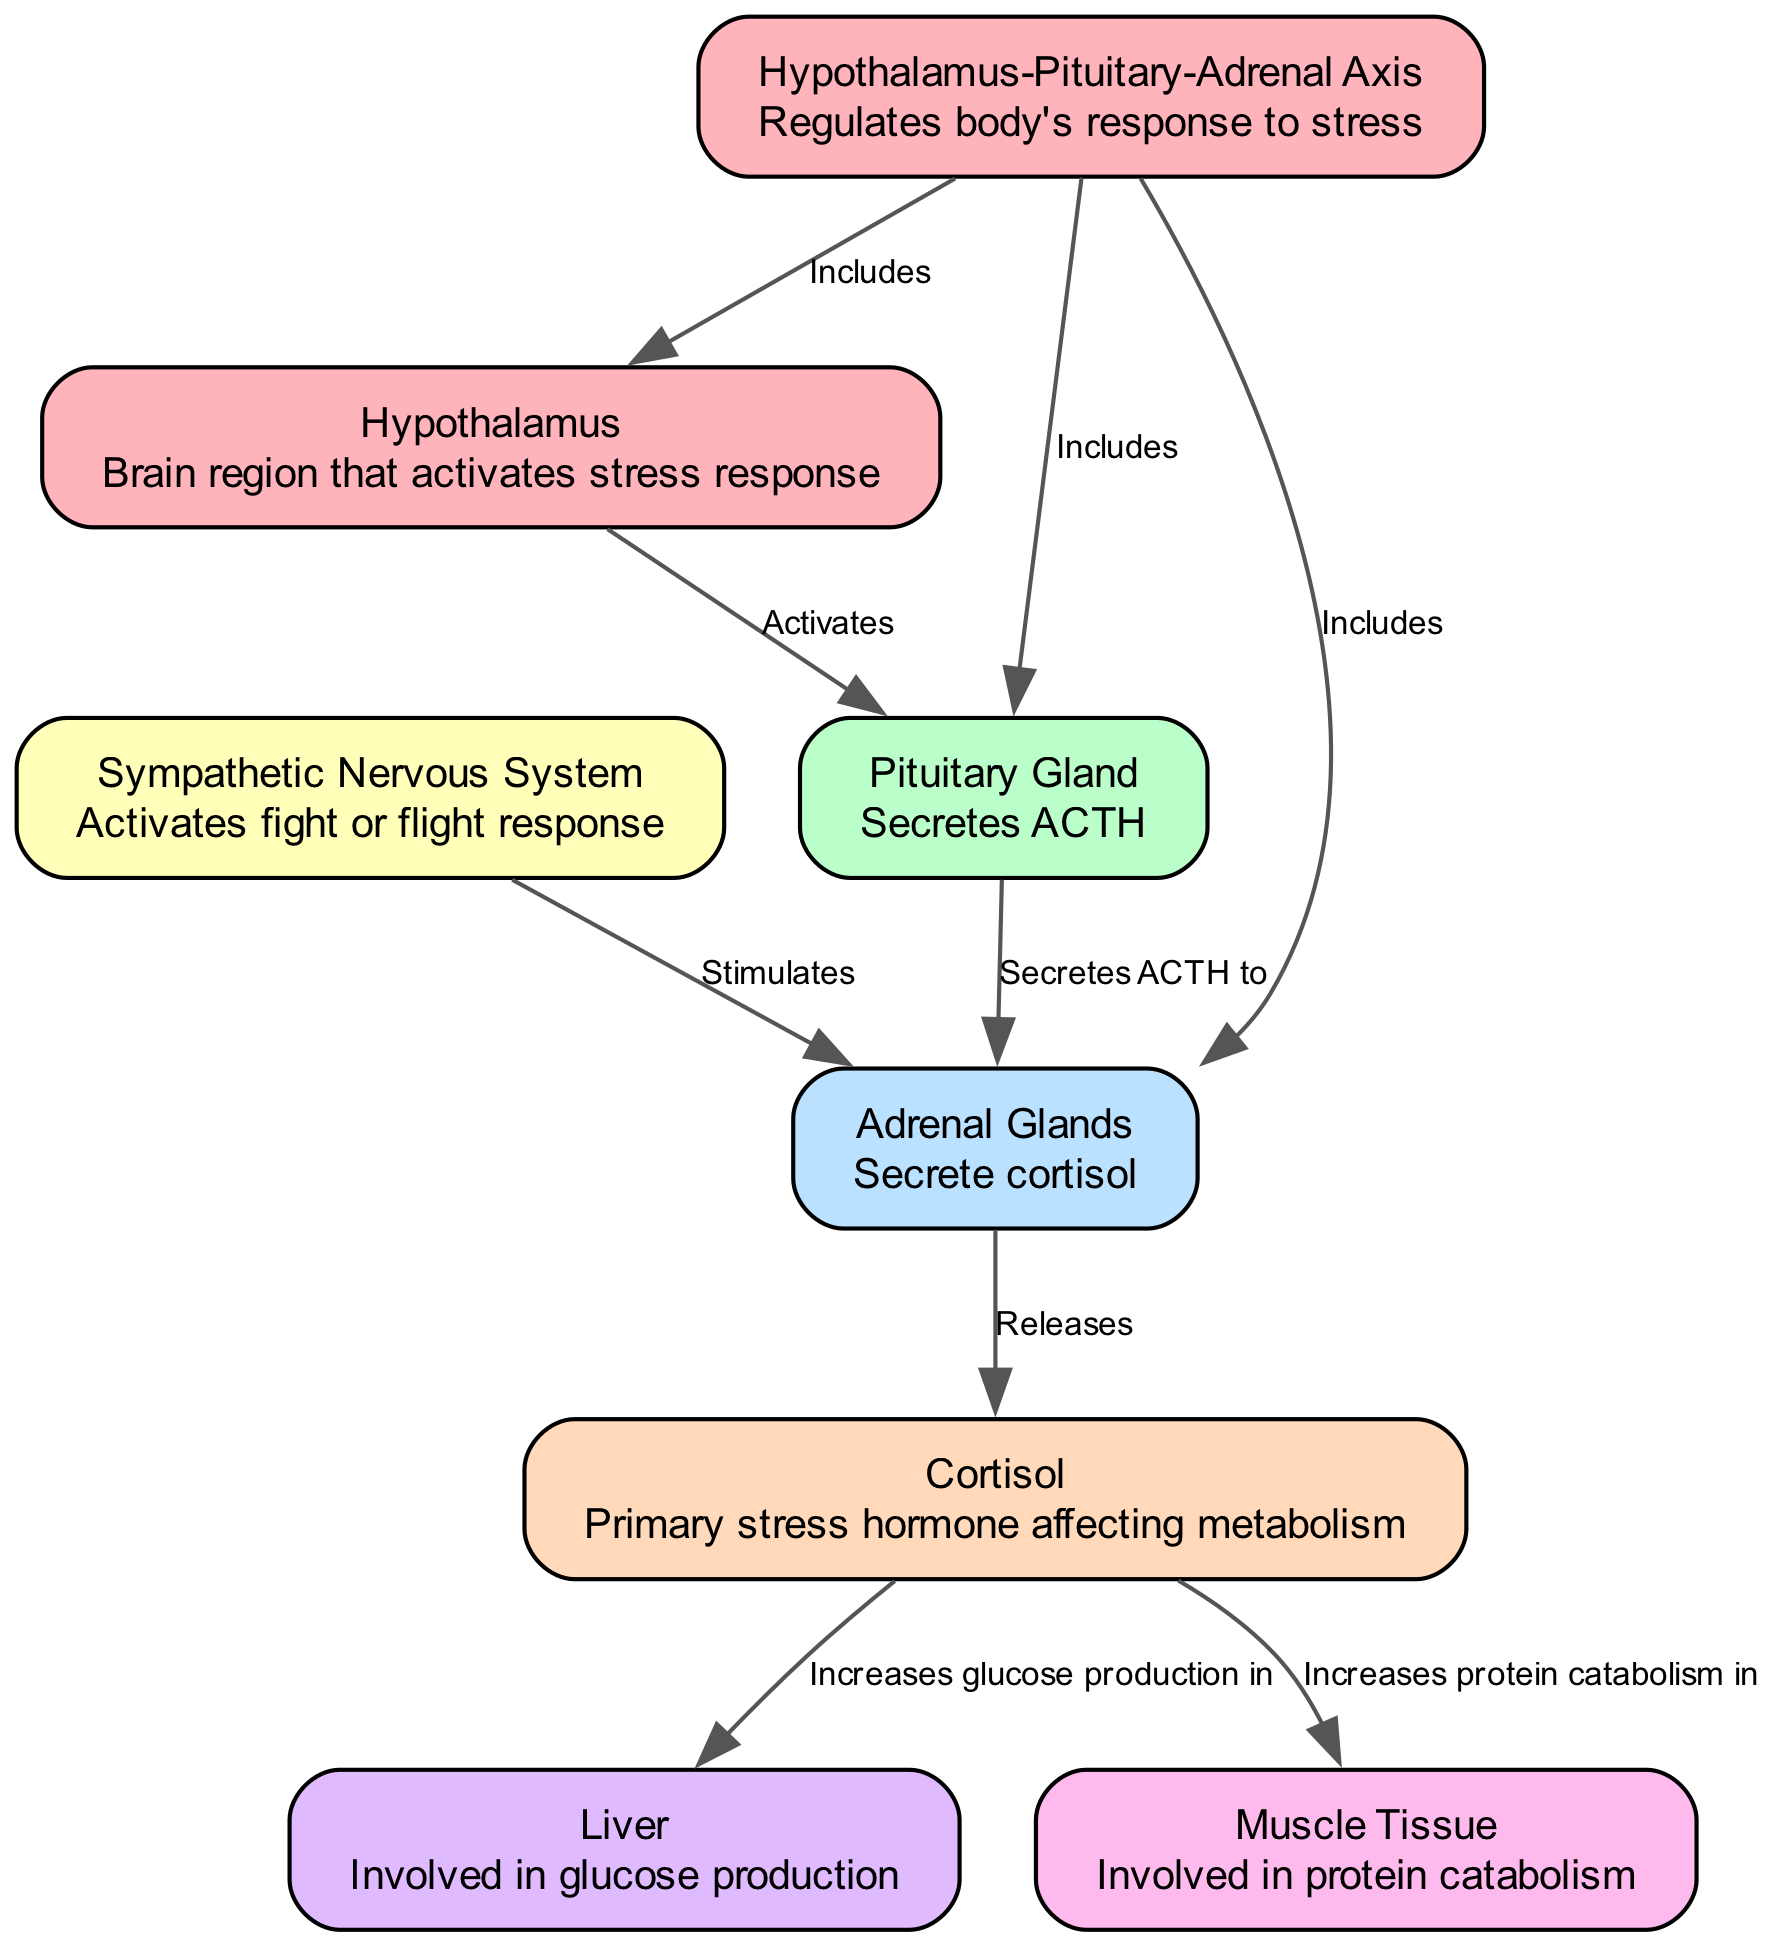What is the primary stress hormone mentioned in the diagram? The diagram indicates that cortisol is the primary stress hormone affecting metabolism. It can be found as a node labeled "Cortisol".
Answer: Cortisol How many nodes are present in the diagram? By counting the distinct nodes listed in the diagram, we find that there are a total of eight nodes representing different components involved in stress responses.
Answer: Eight What does the hypothalamus activate? According to the diagram, the hypothalamus activates the pituitary gland, as depicted by the edge labeled "Activates" from the hypothalamus to the pituitary gland.
Answer: Pituitary Gland Which system is responsible for the "fight or flight" response? The diagram shows that the "Sympathetic Nervous System" is the one that activates the fight or flight response, as indicated in its description.
Answer: Sympathetic Nervous System Increased protein catabolism occurs in which tissue based on the diagram? The diagram clearly states that protein catabolism increases in muscle tissue under the influence of cortisol. This relationship is depicted through the edge connecting cortisol to muscle tissue.
Answer: Muscle Tissue What two components does the Hypothalamus-Pituitary-Adrenal axis include? The Hypothalamus-Pituitary-Adrenal Axis includes the hypothalamus and the pituitary gland, as per the edges labeled "Includes" that point to these two nodes from the axis.
Answer: Hypothalamus and Pituitary Gland What role does cortisol play in relation to glucose production? The diagram indicates that cortisol increases glucose production in the liver, establishing a direct relationship between the two nodes through the labeled edge.
Answer: Increases glucose production in Liver What is the function of the adrenal glands as per the diagram? The diagram specifies that the adrenal glands secrete cortisol, which plays a vital role in the stress response according to its description.
Answer: Secretes cortisol 